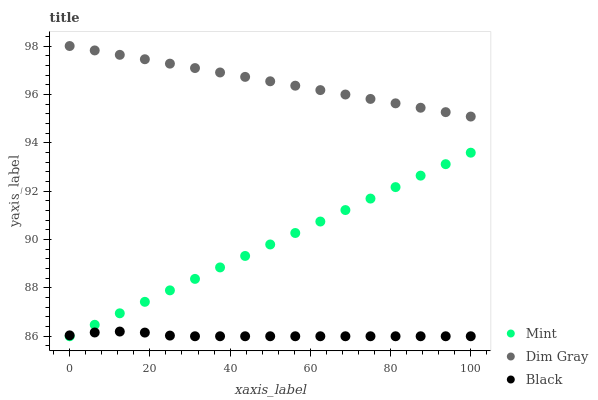Does Black have the minimum area under the curve?
Answer yes or no. Yes. Does Dim Gray have the maximum area under the curve?
Answer yes or no. Yes. Does Mint have the minimum area under the curve?
Answer yes or no. No. Does Mint have the maximum area under the curve?
Answer yes or no. No. Is Mint the smoothest?
Answer yes or no. Yes. Is Black the roughest?
Answer yes or no. Yes. Is Dim Gray the smoothest?
Answer yes or no. No. Is Dim Gray the roughest?
Answer yes or no. No. Does Black have the lowest value?
Answer yes or no. Yes. Does Dim Gray have the lowest value?
Answer yes or no. No. Does Dim Gray have the highest value?
Answer yes or no. Yes. Does Mint have the highest value?
Answer yes or no. No. Is Black less than Dim Gray?
Answer yes or no. Yes. Is Dim Gray greater than Mint?
Answer yes or no. Yes. Does Mint intersect Black?
Answer yes or no. Yes. Is Mint less than Black?
Answer yes or no. No. Is Mint greater than Black?
Answer yes or no. No. Does Black intersect Dim Gray?
Answer yes or no. No. 